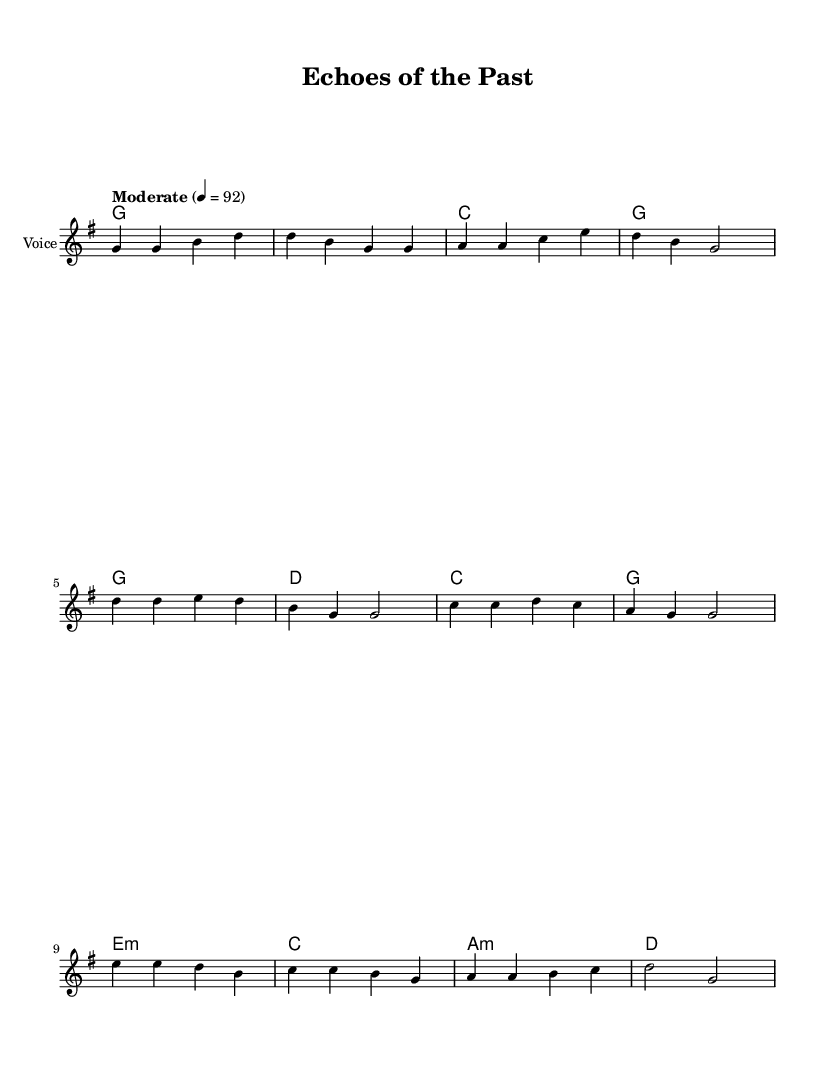What is the key signature of this music? The key signature is G major, which has one sharp (F#). This can be identified from the key given in the global settings of the sheet music.
Answer: G major What is the time signature of this music? The time signature is 4/4, which means there are four beats in each measure. This information is present in the global settings of the music.
Answer: 4/4 What is the tempo marking for this piece? The tempo marking indicates a moderate tempo at quarter note equals 92 beats per minute, specified in the global settings.
Answer: Moderate 4 = 92 How many measures are in the verse section? The verse section consists of four measures, as indicated by the sequences of groups of notes in the melody and the corresponding lyrics.
Answer: 4 What is the main theme expressed in the chorus? The chorus expresses the theme of preserving history and being guardians of memories, as shown in the lyrics.
Answer: Preserving history What type of chords are used in the bridge? The bridge features minor chords such as E minor and A minor, as indicated in the chord mode section.
Answer: Minor What lyrical content reflects the song's historical theme? The lyrics reflect the historical theme by mentioning treasures, artifacts, and stories from the past, emphasizing preservation.
Answer: Treasures and stories 